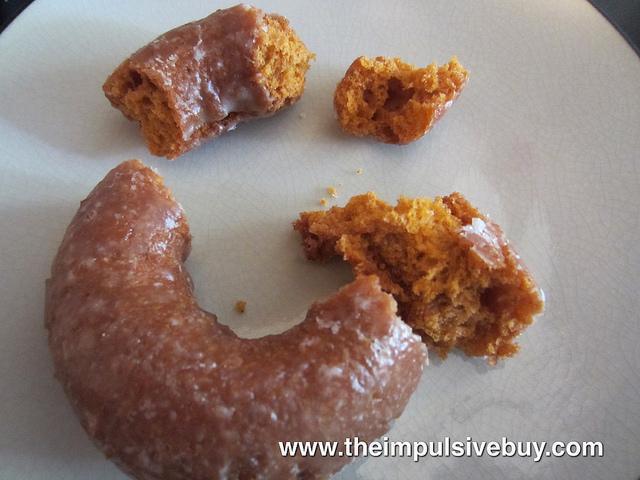How many pieces are there on the plate?
Give a very brief answer. 4. How many donuts are visible?
Give a very brief answer. 4. How many people are wearing red?
Give a very brief answer. 0. 